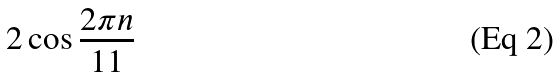Convert formula to latex. <formula><loc_0><loc_0><loc_500><loc_500>2 \cos { \frac { 2 \pi n } { 1 1 } }</formula> 